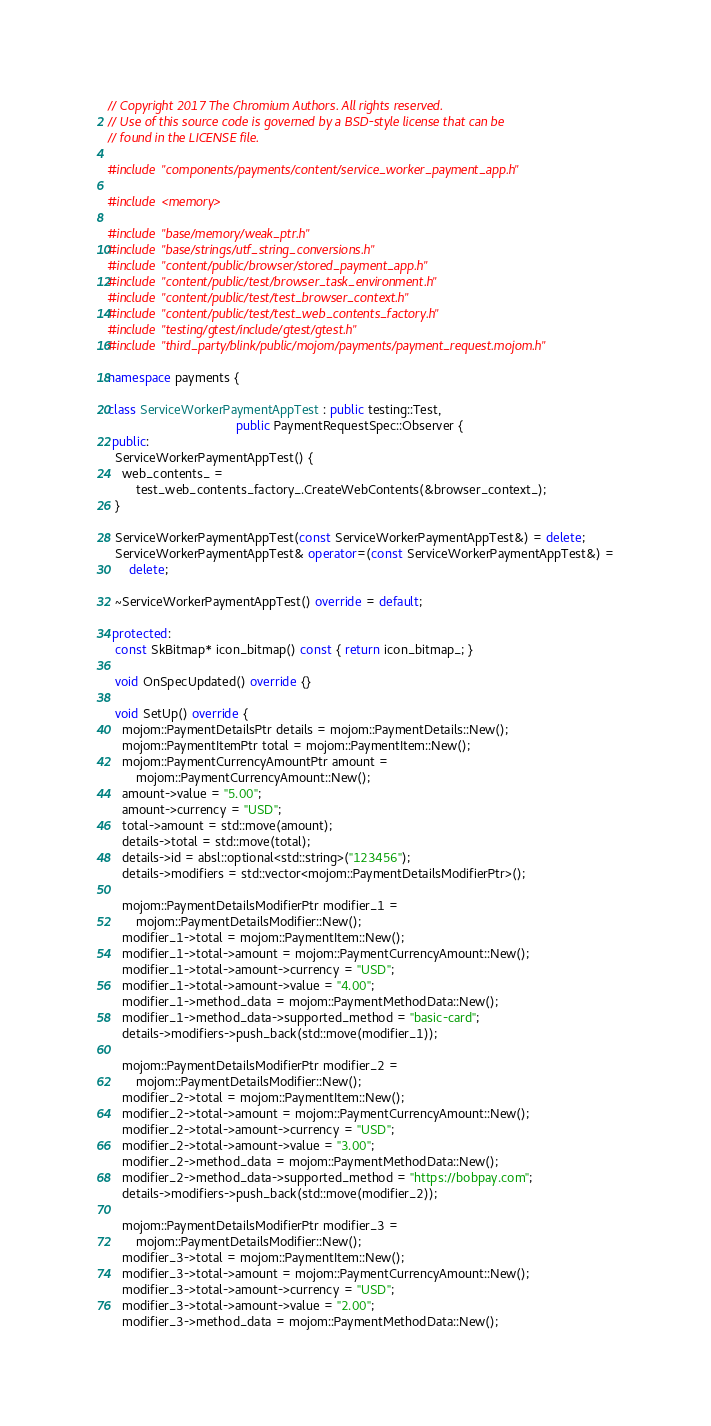Convert code to text. <code><loc_0><loc_0><loc_500><loc_500><_C++_>// Copyright 2017 The Chromium Authors. All rights reserved.
// Use of this source code is governed by a BSD-style license that can be
// found in the LICENSE file.

#include "components/payments/content/service_worker_payment_app.h"

#include <memory>

#include "base/memory/weak_ptr.h"
#include "base/strings/utf_string_conversions.h"
#include "content/public/browser/stored_payment_app.h"
#include "content/public/test/browser_task_environment.h"
#include "content/public/test/test_browser_context.h"
#include "content/public/test/test_web_contents_factory.h"
#include "testing/gtest/include/gtest/gtest.h"
#include "third_party/blink/public/mojom/payments/payment_request.mojom.h"

namespace payments {

class ServiceWorkerPaymentAppTest : public testing::Test,
                                    public PaymentRequestSpec::Observer {
 public:
  ServiceWorkerPaymentAppTest() {
    web_contents_ =
        test_web_contents_factory_.CreateWebContents(&browser_context_);
  }

  ServiceWorkerPaymentAppTest(const ServiceWorkerPaymentAppTest&) = delete;
  ServiceWorkerPaymentAppTest& operator=(const ServiceWorkerPaymentAppTest&) =
      delete;

  ~ServiceWorkerPaymentAppTest() override = default;

 protected:
  const SkBitmap* icon_bitmap() const { return icon_bitmap_; }

  void OnSpecUpdated() override {}

  void SetUp() override {
    mojom::PaymentDetailsPtr details = mojom::PaymentDetails::New();
    mojom::PaymentItemPtr total = mojom::PaymentItem::New();
    mojom::PaymentCurrencyAmountPtr amount =
        mojom::PaymentCurrencyAmount::New();
    amount->value = "5.00";
    amount->currency = "USD";
    total->amount = std::move(amount);
    details->total = std::move(total);
    details->id = absl::optional<std::string>("123456");
    details->modifiers = std::vector<mojom::PaymentDetailsModifierPtr>();

    mojom::PaymentDetailsModifierPtr modifier_1 =
        mojom::PaymentDetailsModifier::New();
    modifier_1->total = mojom::PaymentItem::New();
    modifier_1->total->amount = mojom::PaymentCurrencyAmount::New();
    modifier_1->total->amount->currency = "USD";
    modifier_1->total->amount->value = "4.00";
    modifier_1->method_data = mojom::PaymentMethodData::New();
    modifier_1->method_data->supported_method = "basic-card";
    details->modifiers->push_back(std::move(modifier_1));

    mojom::PaymentDetailsModifierPtr modifier_2 =
        mojom::PaymentDetailsModifier::New();
    modifier_2->total = mojom::PaymentItem::New();
    modifier_2->total->amount = mojom::PaymentCurrencyAmount::New();
    modifier_2->total->amount->currency = "USD";
    modifier_2->total->amount->value = "3.00";
    modifier_2->method_data = mojom::PaymentMethodData::New();
    modifier_2->method_data->supported_method = "https://bobpay.com";
    details->modifiers->push_back(std::move(modifier_2));

    mojom::PaymentDetailsModifierPtr modifier_3 =
        mojom::PaymentDetailsModifier::New();
    modifier_3->total = mojom::PaymentItem::New();
    modifier_3->total->amount = mojom::PaymentCurrencyAmount::New();
    modifier_3->total->amount->currency = "USD";
    modifier_3->total->amount->value = "2.00";
    modifier_3->method_data = mojom::PaymentMethodData::New();</code> 